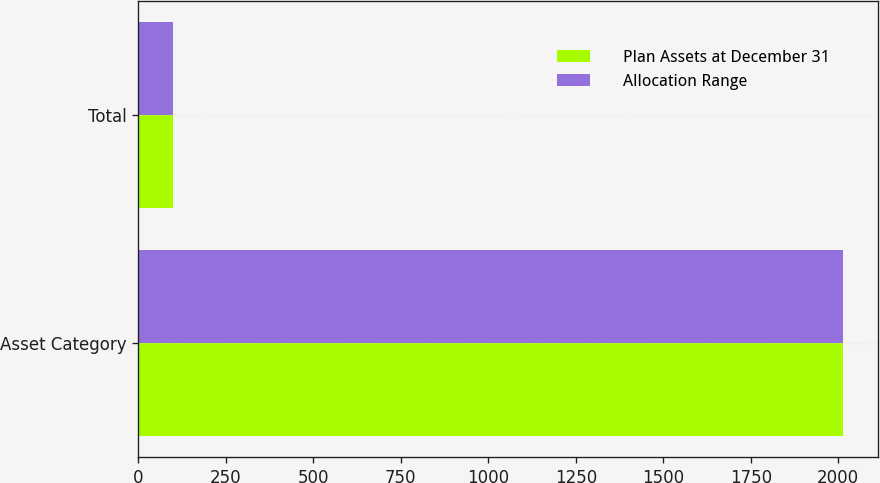Convert chart. <chart><loc_0><loc_0><loc_500><loc_500><stacked_bar_chart><ecel><fcel>Asset Category<fcel>Total<nl><fcel>Plan Assets at December 31<fcel>2014<fcel>100<nl><fcel>Allocation Range<fcel>2013<fcel>100<nl></chart> 